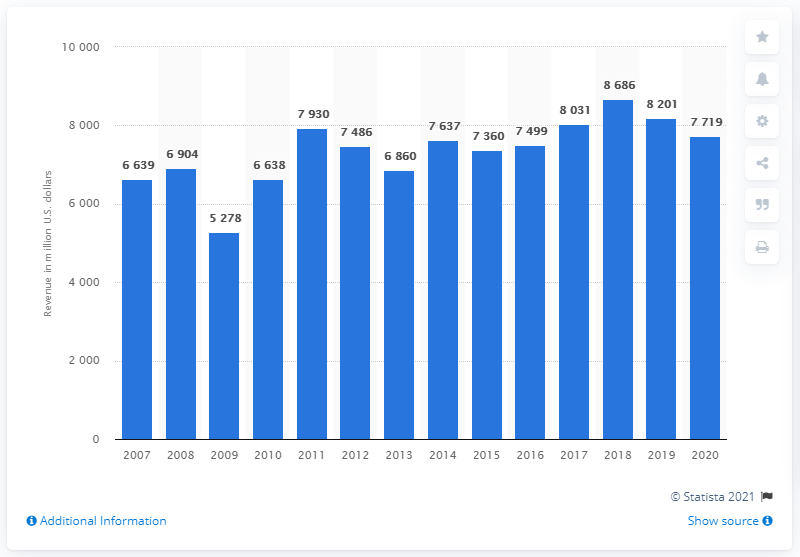Highlight a few significant elements in this photo. The previous year's revenue for Williams Companies was 8201. Williams Companies reported a revenue of 7,719 in 2020. 